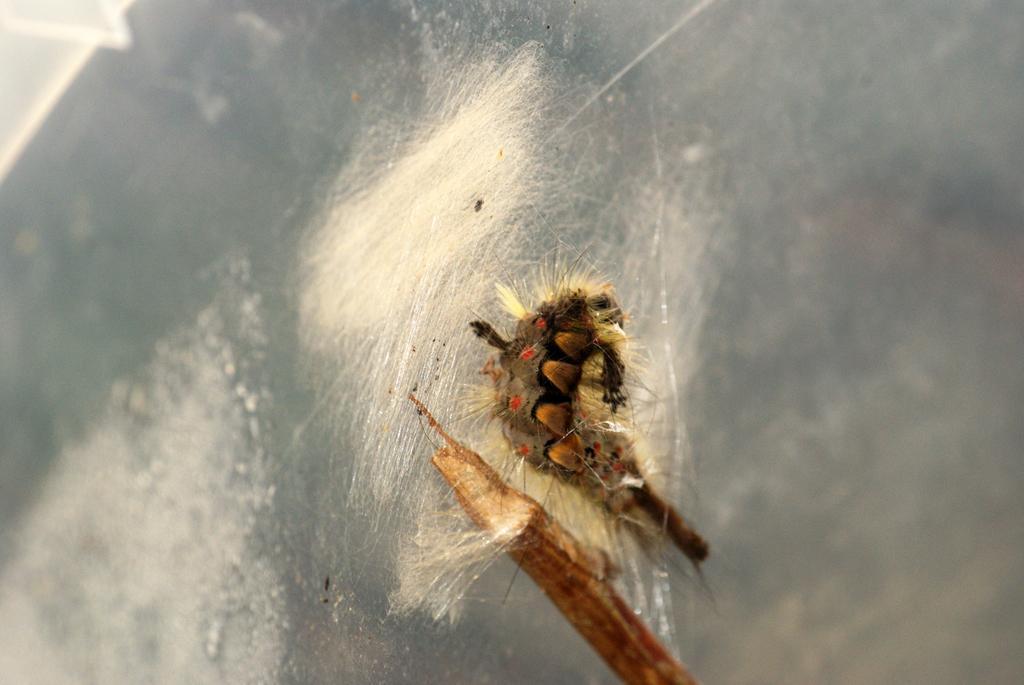Could you give a brief overview of what you see in this image? In this image we can see two caterpillars on the surface. 